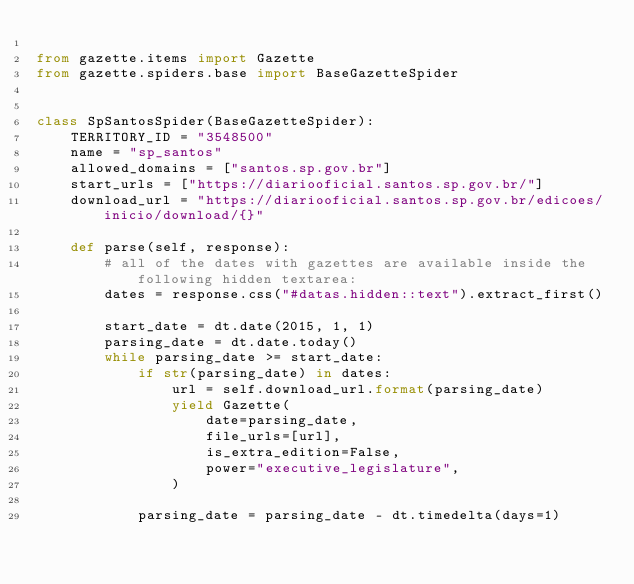<code> <loc_0><loc_0><loc_500><loc_500><_Python_>
from gazette.items import Gazette
from gazette.spiders.base import BaseGazetteSpider


class SpSantosSpider(BaseGazetteSpider):
    TERRITORY_ID = "3548500"
    name = "sp_santos"
    allowed_domains = ["santos.sp.gov.br"]
    start_urls = ["https://diariooficial.santos.sp.gov.br/"]
    download_url = "https://diariooficial.santos.sp.gov.br/edicoes/inicio/download/{}"

    def parse(self, response):
        # all of the dates with gazettes are available inside the following hidden textarea:
        dates = response.css("#datas.hidden::text").extract_first()

        start_date = dt.date(2015, 1, 1)
        parsing_date = dt.date.today()
        while parsing_date >= start_date:
            if str(parsing_date) in dates:
                url = self.download_url.format(parsing_date)
                yield Gazette(
                    date=parsing_date,
                    file_urls=[url],
                    is_extra_edition=False,
                    power="executive_legislature",
                )

            parsing_date = parsing_date - dt.timedelta(days=1)
</code> 